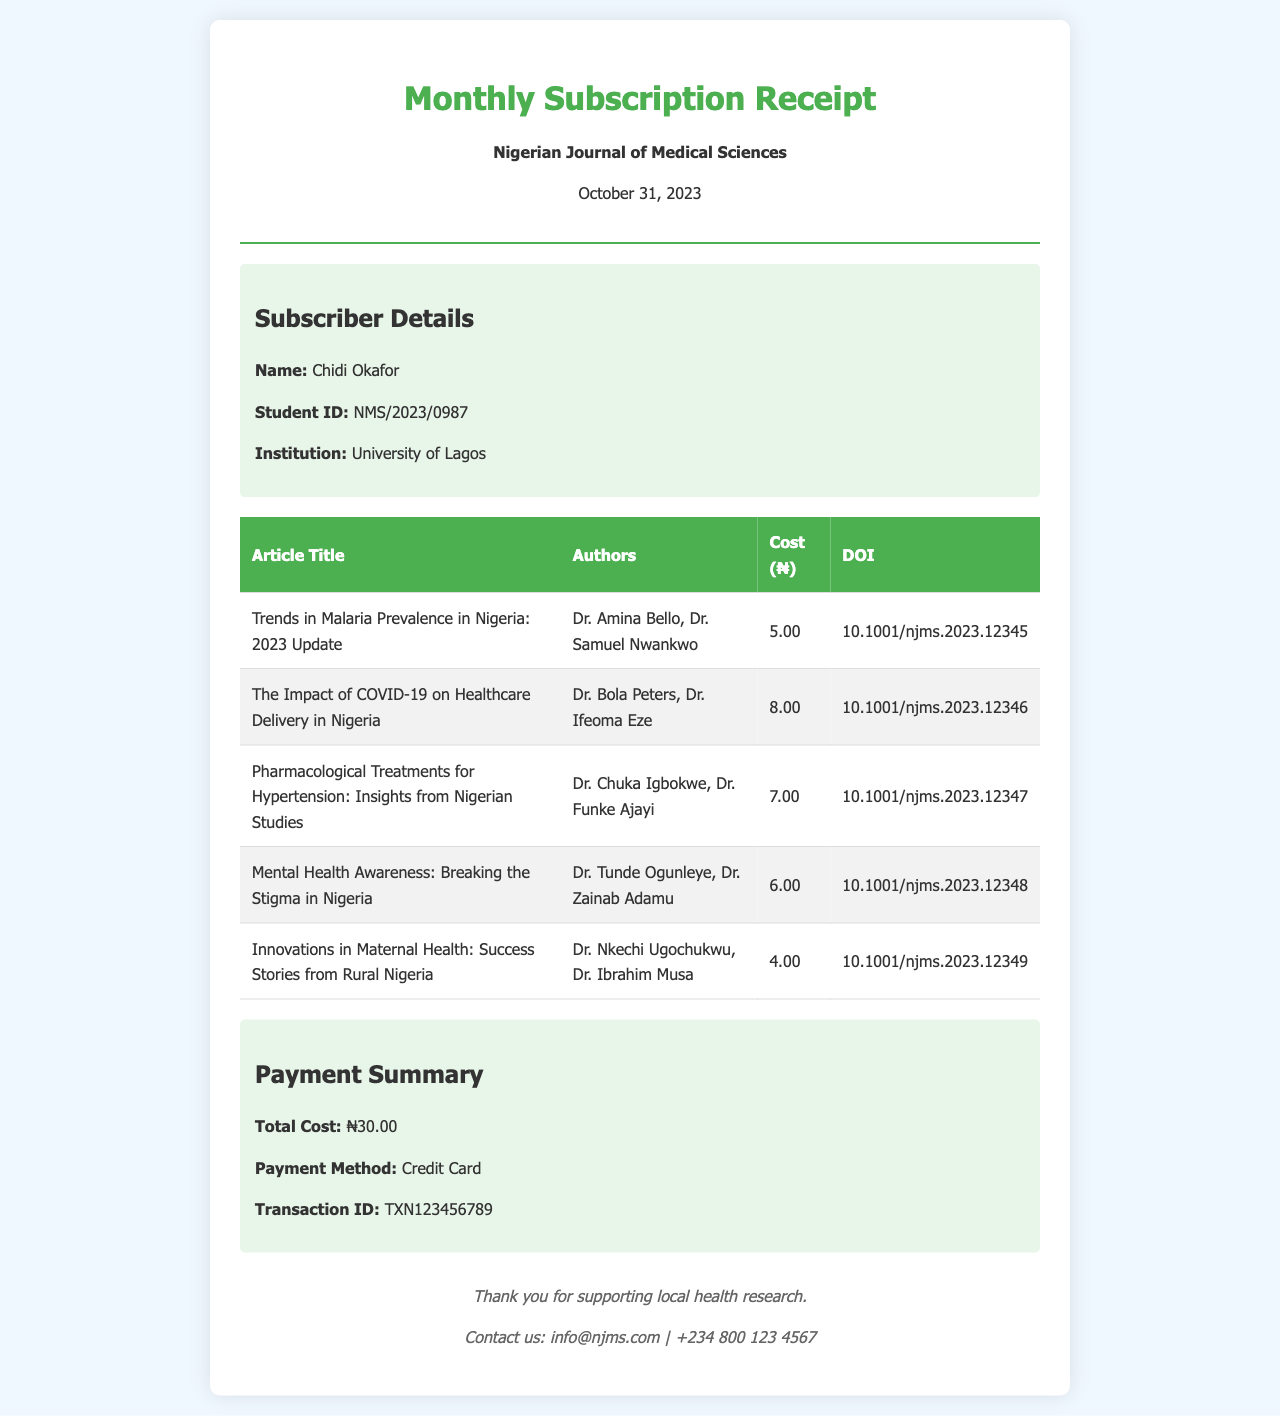what is the name of the subscriber? The subscriber’s name is provided in the subscriber details section.
Answer: Chidi Okafor what is the total cost of the articles accessed? The total cost is mentioned in the payment summary section of the receipt.
Answer: ₦30.00 what is the transaction ID for the payment? The transaction ID can be found in the payment summary section of the receipt.
Answer: TXN123456789 how many articles were accessed? The number of articles is counted from the itemized list in the table.
Answer: 5 who are the authors of the first article? The authors of the first article can be found in the corresponding row of the table.
Answer: Dr. Amina Bello, Dr. Samuel Nwankwo what payment method was used? The payment method is specified in the payment summary section.
Answer: Credit Card which article has the highest cost? The article with the highest cost is determined by comparing the costs listed in the table.
Answer: The Impact of COVID-19 on Healthcare Delivery in Nigeria what is the date of the receipt? The date of the receipt is stated at the top of the document.
Answer: October 31, 2023 what institution is the subscriber affiliated with? The subscriber's institution is mentioned in the subscriber details section.
Answer: University of Lagos 